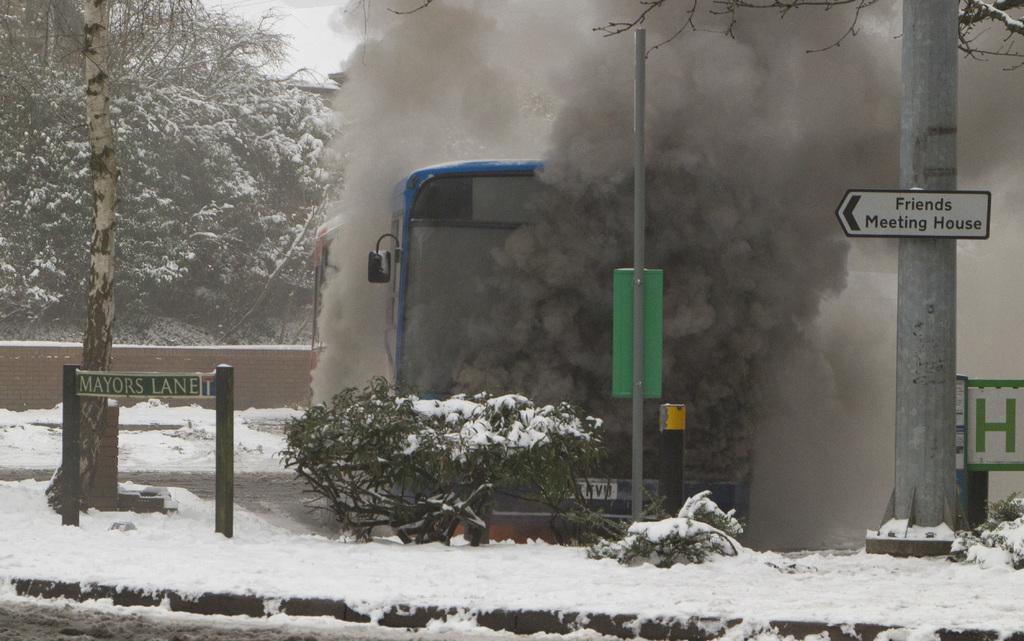Describe this image in one or two sentences. In this image we can see a vehicle. We can see the smoke in the image. We can see the snow in the image. There are few trees and plants in the image. There is some text on the boards. 